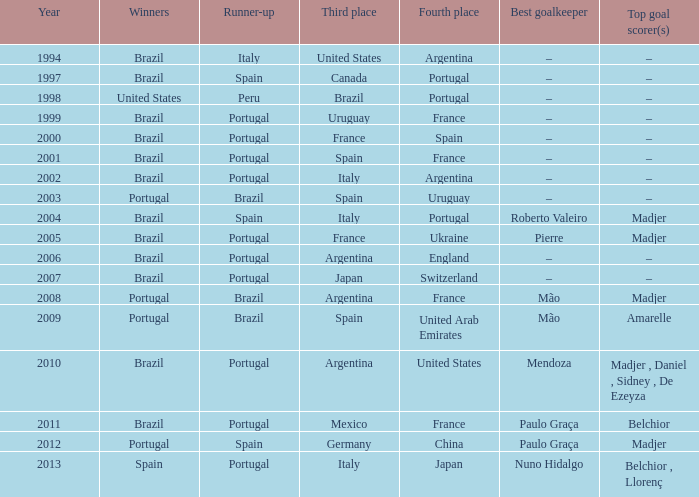In which year did portugal take second place, italy secure third position, and nuno hidalgo serve as the goalkeeper? 2013.0. 